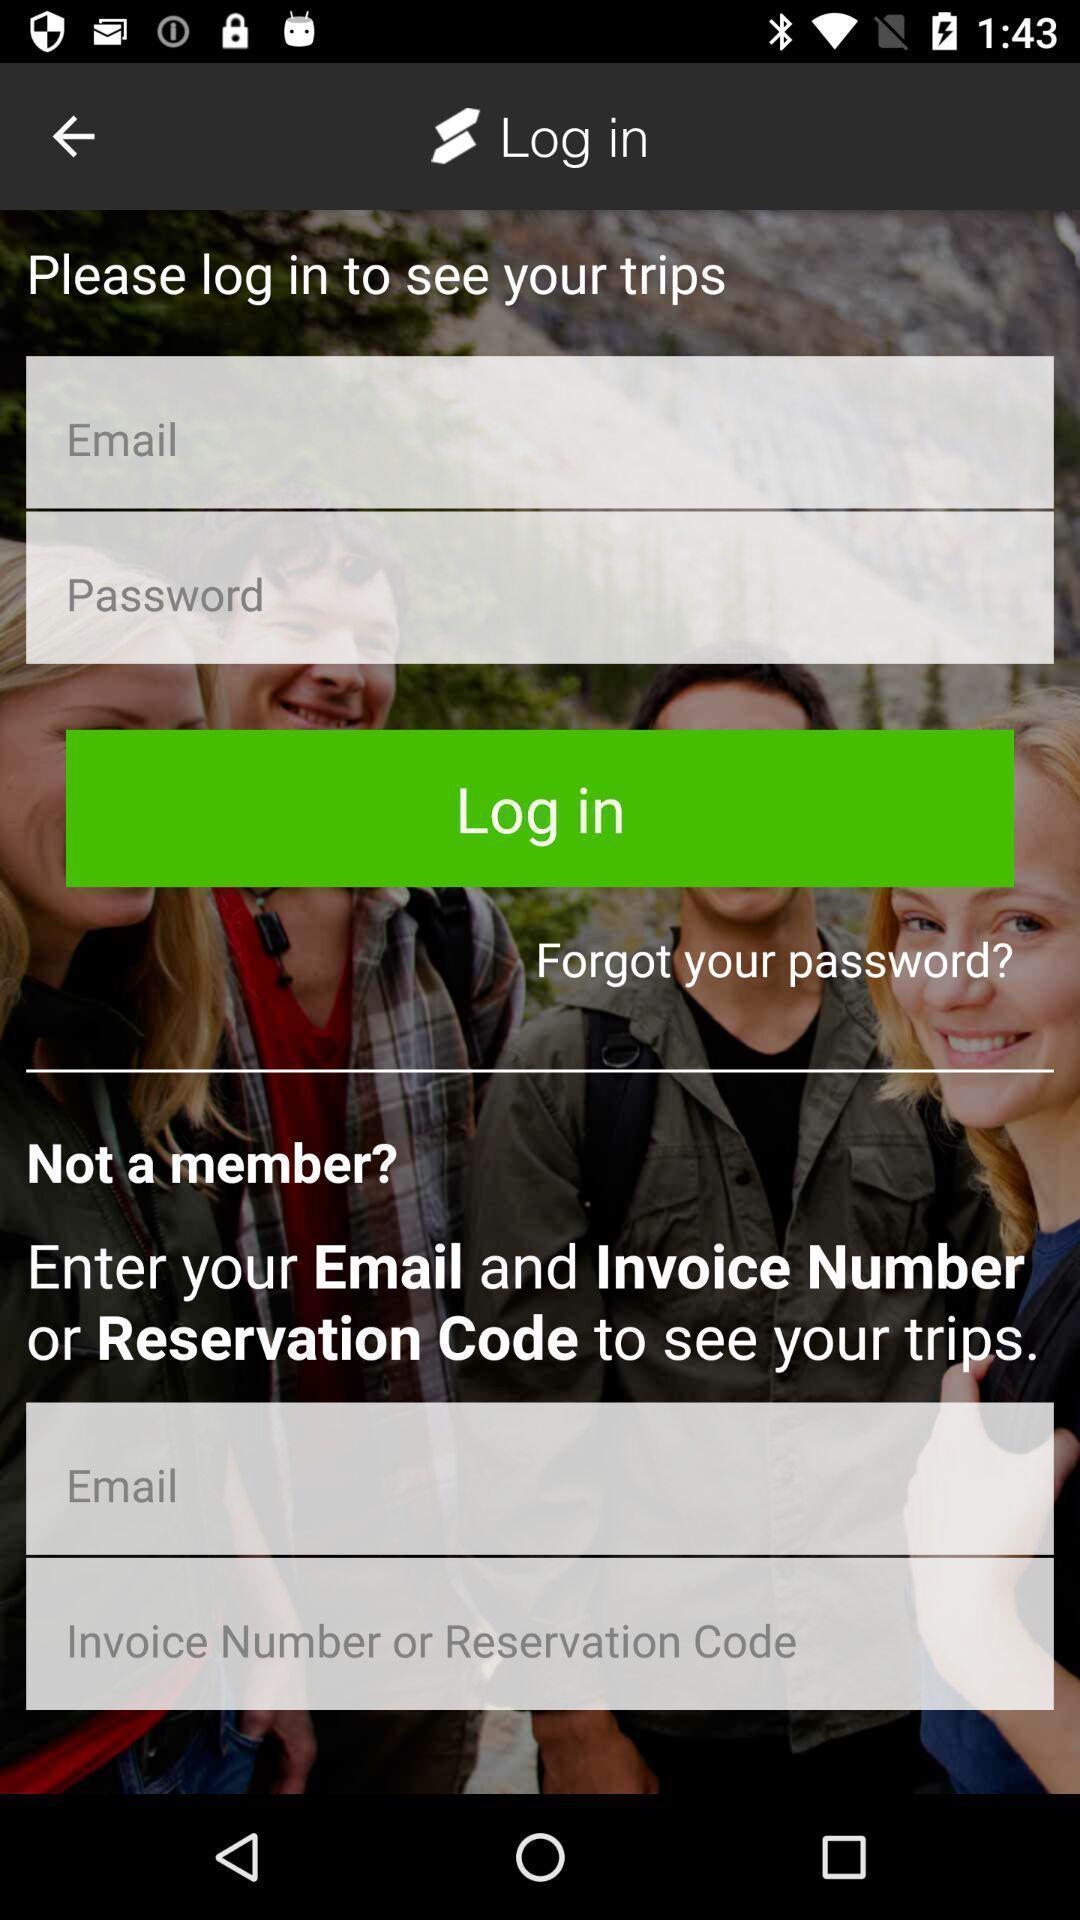Summarize the main components in this picture. Login page. 